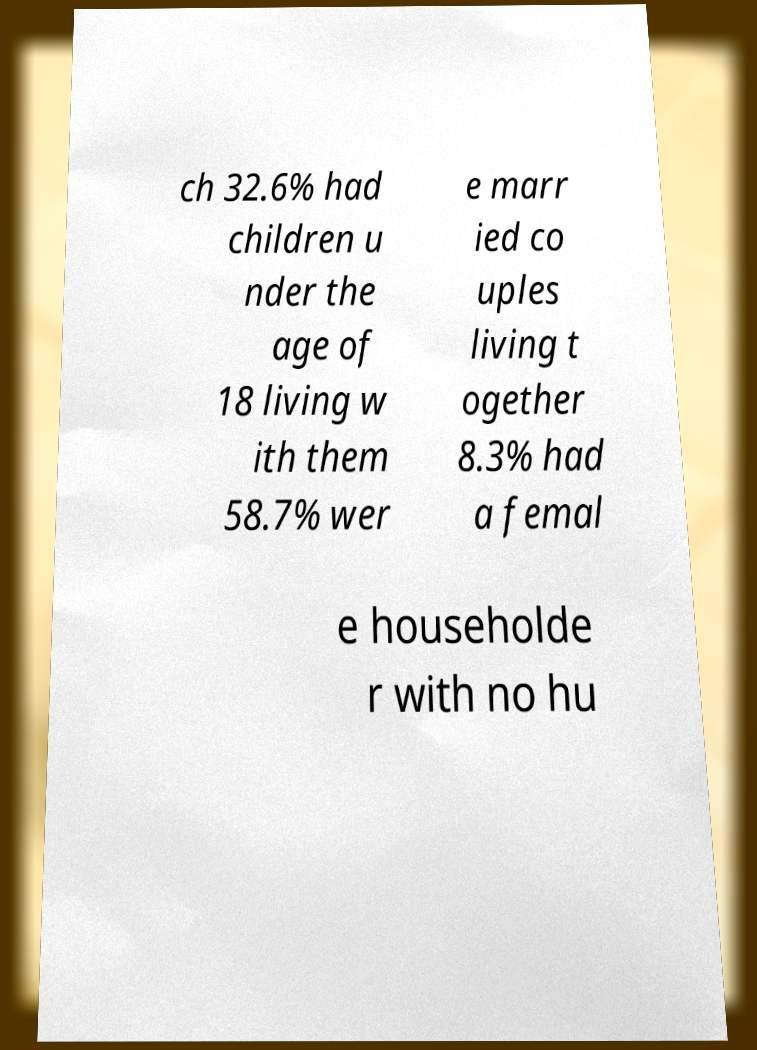Please identify and transcribe the text found in this image. ch 32.6% had children u nder the age of 18 living w ith them 58.7% wer e marr ied co uples living t ogether 8.3% had a femal e householde r with no hu 